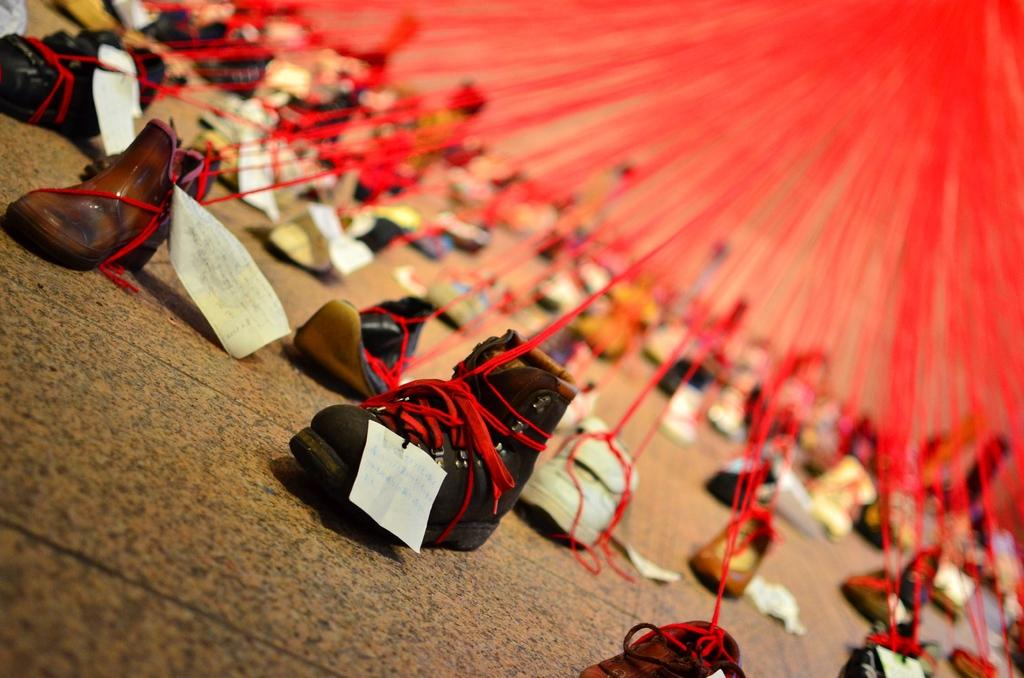What is on the ground in the image? There is footwear on the ground in the image. What else can be seen in the image besides footwear? There are papers and threads visible in the image. Can you describe the background of the image? The background of the image is blurry. What type of jar is present in the image? There is no jar present in the image. How is the fire being used in the image? There is no fire present in the image. 